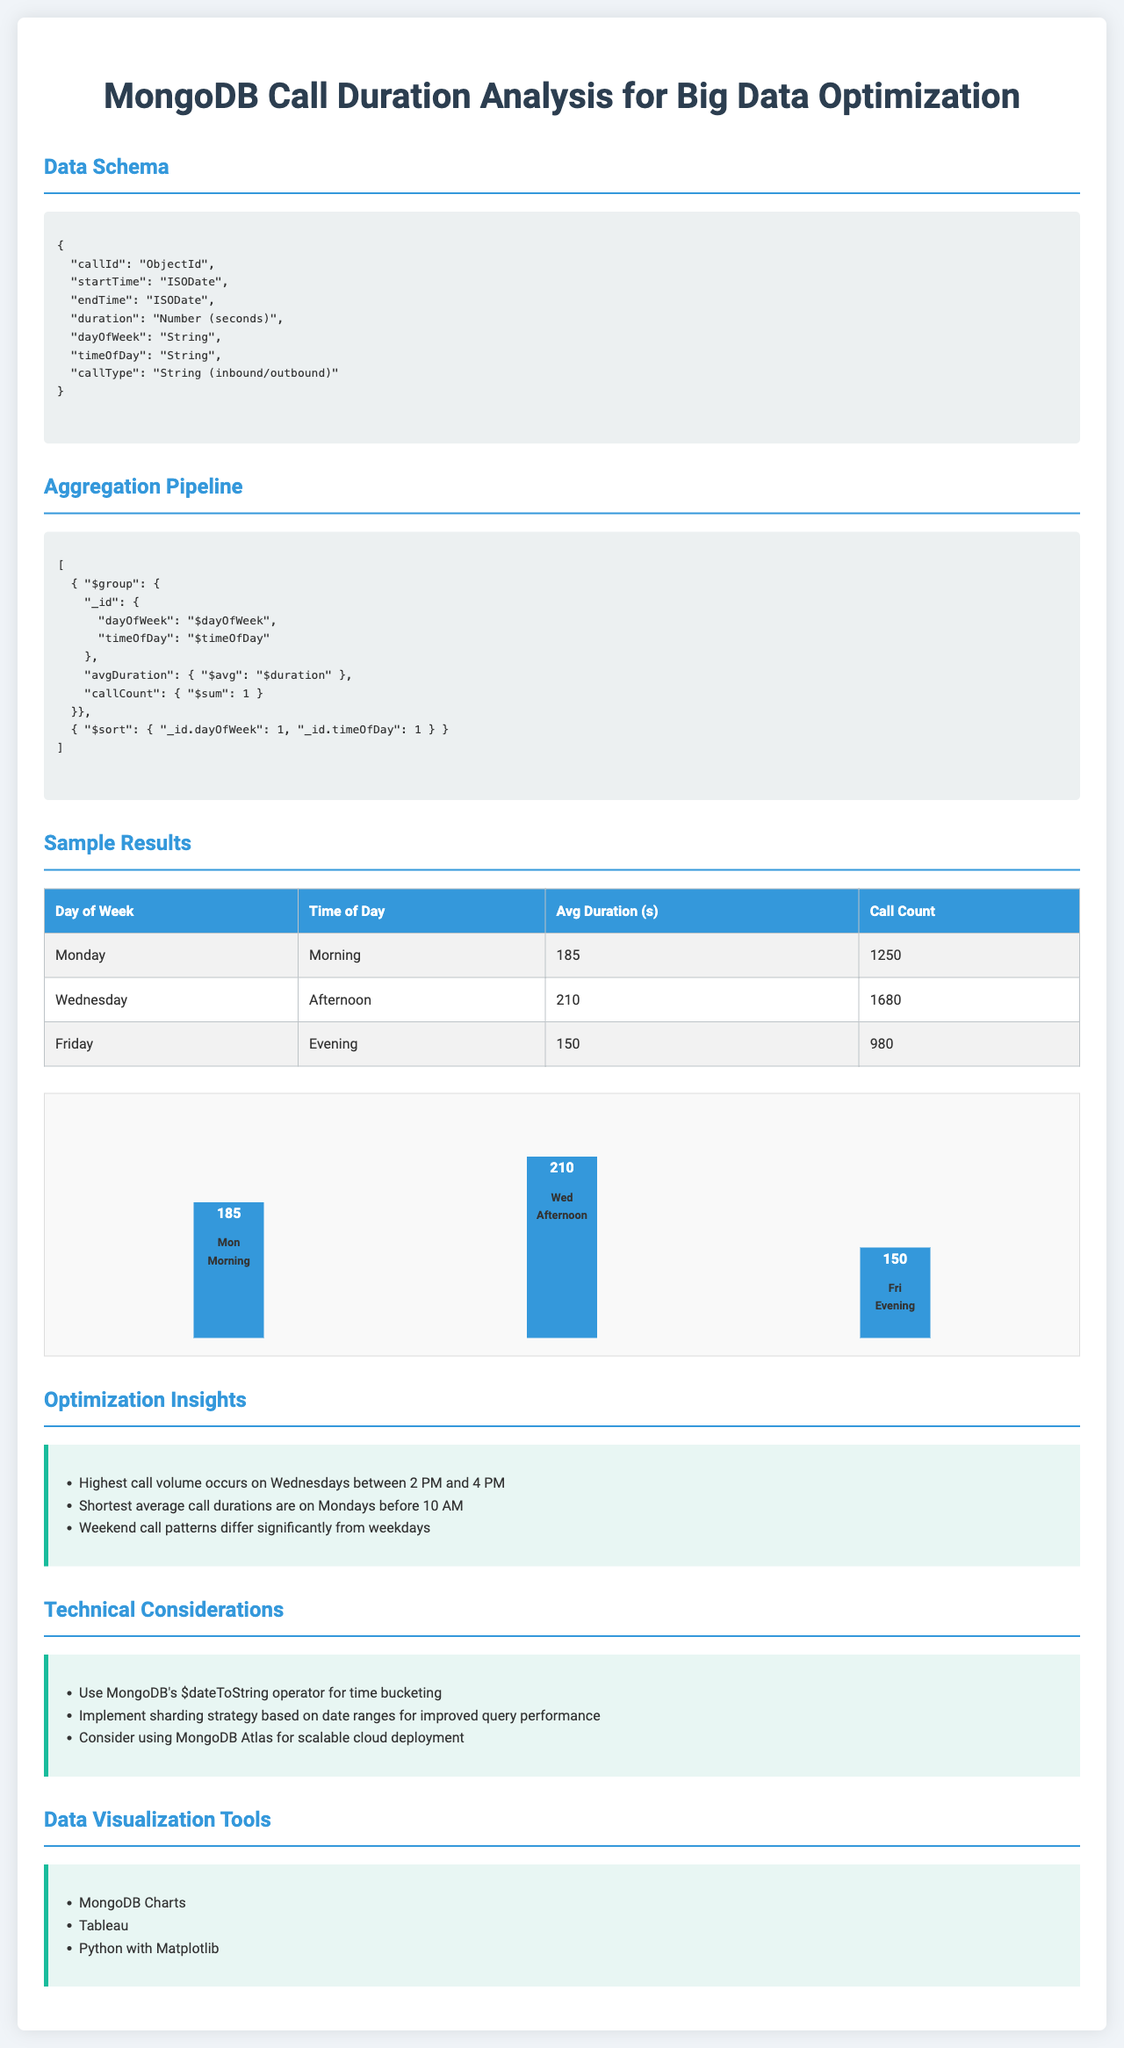What is the average call duration on Mondays in the morning? The average call duration on Mondays in the morning is provided in the sample results table, which states 185 seconds.
Answer: 185 seconds How many calls were recorded on Wednesdays in the afternoon? The call count for Wednesdays in the afternoon is found in the sample results table, showing a total of 1680 calls.
Answer: 1680 Which day of the week has the highest average call duration? The document indicates that Wednesdays in the afternoon have the highest average duration of 210 seconds.
Answer: Wednesday What is the call count for Friday evenings? The sample results table states that there were 980 calls on Friday evenings.
Answer: 980 What is one optimization insight mentioned in the document? The insights section lists several observations; one of them is that the highest call volume occurs on Wednesdays between 2 PM and 4 PM.
Answer: Highest call volume on Wednesdays What are the technical considerations for improving query performance? The document suggests implementing a sharding strategy based on date ranges to enhance query performance.
Answer: Sharding strategy Which time bucket shows the lowest average call duration? The data indicates that the shortest average call durations are on Mondays before 10 AM.
Answer: Mondays before 10 AM What type of chart is used for data visualization in the document? The visualization section mentions MongoDB Charts as one tool for visualizing the data.
Answer: MongoDB Charts 